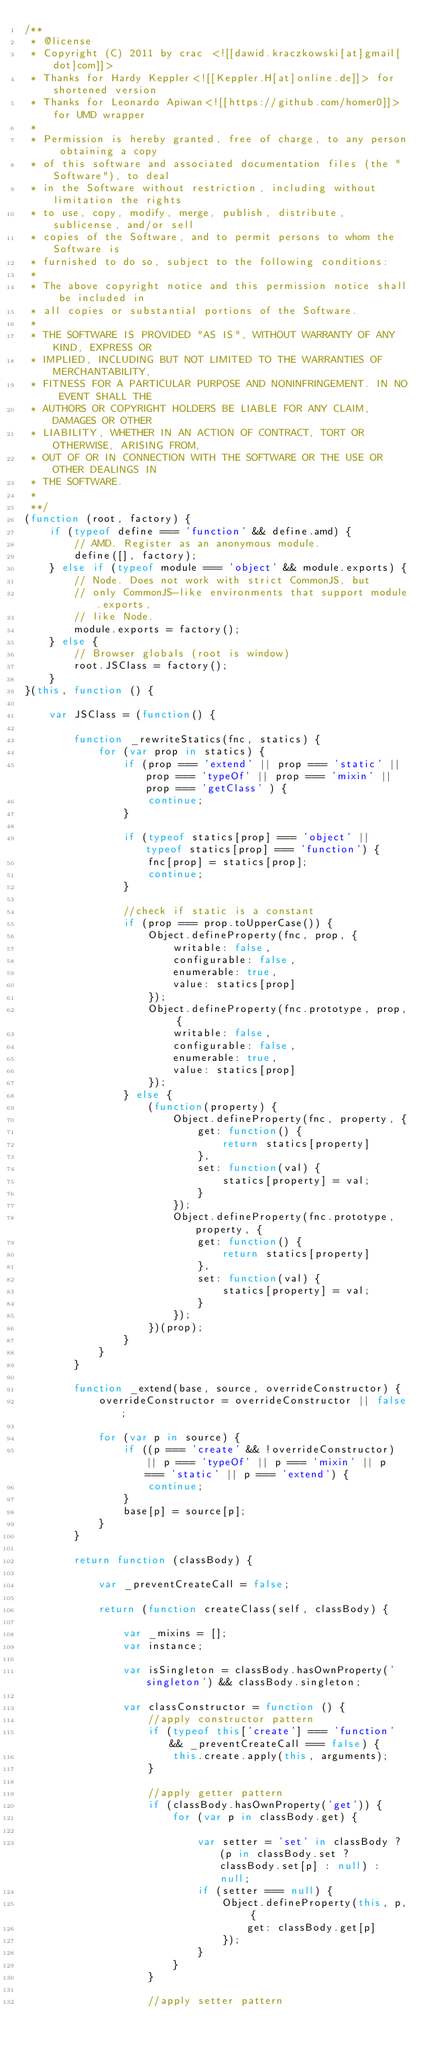Convert code to text. <code><loc_0><loc_0><loc_500><loc_500><_JavaScript_>/**
 * @license
 * Copyright (C) 2011 by crac <![[dawid.kraczkowski[at]gmail[dot]com]]>
 * Thanks for Hardy Keppler<![[Keppler.H[at]online.de]]> for shortened version
 * Thanks for Leonardo Apiwan<![[https://github.com/homer0]]> for UMD wrapper
 *
 * Permission is hereby granted, free of charge, to any person obtaining a copy
 * of this software and associated documentation files (the "Software"), to deal
 * in the Software without restriction, including without limitation the rights
 * to use, copy, modify, merge, publish, distribute, sublicense, and/or sell
 * copies of the Software, and to permit persons to whom the Software is
 * furnished to do so, subject to the following conditions:
 *
 * The above copyright notice and this permission notice shall be included in
 * all copies or substantial portions of the Software.
 *
 * THE SOFTWARE IS PROVIDED "AS IS", WITHOUT WARRANTY OF ANY KIND, EXPRESS OR
 * IMPLIED, INCLUDING BUT NOT LIMITED TO THE WARRANTIES OF MERCHANTABILITY,
 * FITNESS FOR A PARTICULAR PURPOSE AND NONINFRINGEMENT. IN NO EVENT SHALL THE
 * AUTHORS OR COPYRIGHT HOLDERS BE LIABLE FOR ANY CLAIM, DAMAGES OR OTHER
 * LIABILITY, WHETHER IN AN ACTION OF CONTRACT, TORT OR OTHERWISE, ARISING FROM,
 * OUT OF OR IN CONNECTION WITH THE SOFTWARE OR THE USE OR OTHER DEALINGS IN
 * THE SOFTWARE.
 *
 **/
(function (root, factory) {
    if (typeof define === 'function' && define.amd) {
        // AMD. Register as an anonymous module.
        define([], factory);
    } else if (typeof module === 'object' && module.exports) {
        // Node. Does not work with strict CommonJS, but
        // only CommonJS-like environments that support module.exports,
        // like Node.
        module.exports = factory();
    } else {
        // Browser globals (root is window)
        root.JSClass = factory();
    }
}(this, function () {

    var JSClass = (function() {

        function _rewriteStatics(fnc, statics) {
            for (var prop in statics) {
                if (prop === 'extend' || prop === 'static' || prop === 'typeOf' || prop === 'mixin' || prop === 'getClass' ) {
                    continue;
                }

                if (typeof statics[prop] === 'object' || typeof statics[prop] === 'function') {
                    fnc[prop] = statics[prop];
                    continue;
                }

                //check if static is a constant
                if (prop === prop.toUpperCase()) {
                    Object.defineProperty(fnc, prop, {
                        writable: false,
                        configurable: false,
                        enumerable: true,
                        value: statics[prop]
                    });
                    Object.defineProperty(fnc.prototype, prop, {
                        writable: false,
                        configurable: false,
                        enumerable: true,
                        value: statics[prop]
                    });
                } else {
                    (function(property) {
                        Object.defineProperty(fnc, property, {
                            get: function() {
                                return statics[property]
                            },
                            set: function(val) {
                                statics[property] = val;
                            }
                        });
                        Object.defineProperty(fnc.prototype, property, {
                            get: function() {
                                return statics[property]
                            },
                            set: function(val) {
                                statics[property] = val;
                            }
                        });
                    })(prop);
                }
            }
        }

        function _extend(base, source, overrideConstructor) {
            overrideConstructor = overrideConstructor || false;

            for (var p in source) {
                if ((p === 'create' && !overrideConstructor) || p === 'typeOf' || p === 'mixin' || p === 'static' || p === 'extend') {
                    continue;
                }
                base[p] = source[p];
            }
        }

        return function (classBody) {

            var _preventCreateCall = false;

            return (function createClass(self, classBody) {

                var _mixins = [];
                var instance;

                var isSingleton = classBody.hasOwnProperty('singleton') && classBody.singleton;

                var classConstructor = function () {
                    //apply constructor pattern
                    if (typeof this['create'] === 'function' && _preventCreateCall === false) {
                        this.create.apply(this, arguments);
                    }

                    //apply getter pattern
                    if (classBody.hasOwnProperty('get')) {
                        for (var p in classBody.get) {

                            var setter = 'set' in classBody ? (p in classBody.set ? classBody.set[p] : null) : null;
                            if (setter === null) {
                                Object.defineProperty(this, p, {
                                    get: classBody.get[p]
                                });
                            }
                        }
                    }

                    //apply setter pattern</code> 